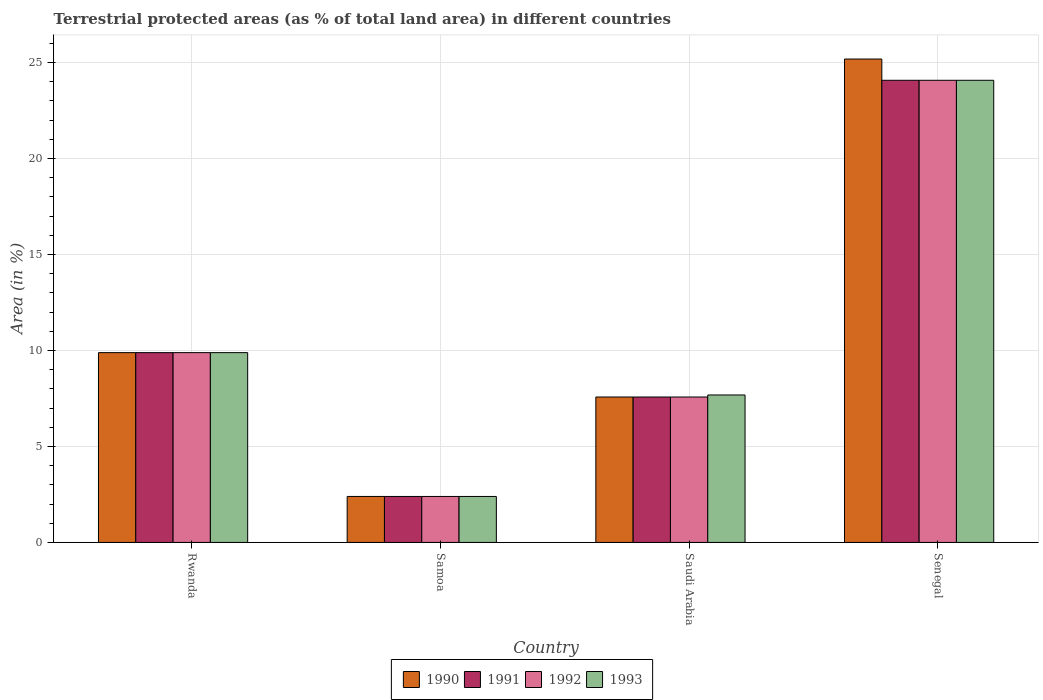How many groups of bars are there?
Offer a terse response. 4. How many bars are there on the 4th tick from the left?
Your answer should be very brief. 4. What is the label of the 2nd group of bars from the left?
Ensure brevity in your answer.  Samoa. In how many cases, is the number of bars for a given country not equal to the number of legend labels?
Offer a very short reply. 0. What is the percentage of terrestrial protected land in 1992 in Samoa?
Offer a very short reply. 2.4. Across all countries, what is the maximum percentage of terrestrial protected land in 1993?
Provide a succinct answer. 24.07. Across all countries, what is the minimum percentage of terrestrial protected land in 1990?
Offer a terse response. 2.4. In which country was the percentage of terrestrial protected land in 1993 maximum?
Your response must be concise. Senegal. In which country was the percentage of terrestrial protected land in 1991 minimum?
Your answer should be compact. Samoa. What is the total percentage of terrestrial protected land in 1991 in the graph?
Give a very brief answer. 43.93. What is the difference between the percentage of terrestrial protected land in 1990 in Rwanda and that in Samoa?
Keep it short and to the point. 7.49. What is the difference between the percentage of terrestrial protected land in 1992 in Rwanda and the percentage of terrestrial protected land in 1993 in Senegal?
Your answer should be compact. -14.19. What is the average percentage of terrestrial protected land in 1993 per country?
Your answer should be compact. 11.01. What is the difference between the percentage of terrestrial protected land of/in 1991 and percentage of terrestrial protected land of/in 1990 in Senegal?
Your response must be concise. -1.11. In how many countries, is the percentage of terrestrial protected land in 1991 greater than 19 %?
Give a very brief answer. 1. What is the ratio of the percentage of terrestrial protected land in 1990 in Samoa to that in Saudi Arabia?
Make the answer very short. 0.32. Is the percentage of terrestrial protected land in 1991 in Rwanda less than that in Senegal?
Offer a very short reply. Yes. What is the difference between the highest and the second highest percentage of terrestrial protected land in 1993?
Offer a very short reply. 14.19. What is the difference between the highest and the lowest percentage of terrestrial protected land in 1993?
Offer a terse response. 21.68. In how many countries, is the percentage of terrestrial protected land in 1993 greater than the average percentage of terrestrial protected land in 1993 taken over all countries?
Provide a succinct answer. 1. Is it the case that in every country, the sum of the percentage of terrestrial protected land in 1990 and percentage of terrestrial protected land in 1993 is greater than the percentage of terrestrial protected land in 1991?
Make the answer very short. Yes. How many bars are there?
Make the answer very short. 16. Are all the bars in the graph horizontal?
Provide a succinct answer. No. Are the values on the major ticks of Y-axis written in scientific E-notation?
Ensure brevity in your answer.  No. Does the graph contain any zero values?
Provide a succinct answer. No. Does the graph contain grids?
Your answer should be compact. Yes. What is the title of the graph?
Offer a terse response. Terrestrial protected areas (as % of total land area) in different countries. Does "1989" appear as one of the legend labels in the graph?
Offer a very short reply. No. What is the label or title of the X-axis?
Ensure brevity in your answer.  Country. What is the label or title of the Y-axis?
Keep it short and to the point. Area (in %). What is the Area (in %) of 1990 in Rwanda?
Give a very brief answer. 9.89. What is the Area (in %) of 1991 in Rwanda?
Keep it short and to the point. 9.89. What is the Area (in %) in 1992 in Rwanda?
Your answer should be compact. 9.89. What is the Area (in %) of 1993 in Rwanda?
Your answer should be very brief. 9.89. What is the Area (in %) of 1990 in Samoa?
Offer a terse response. 2.4. What is the Area (in %) of 1991 in Samoa?
Your response must be concise. 2.4. What is the Area (in %) in 1992 in Samoa?
Provide a succinct answer. 2.4. What is the Area (in %) of 1993 in Samoa?
Your answer should be very brief. 2.4. What is the Area (in %) of 1990 in Saudi Arabia?
Your answer should be compact. 7.58. What is the Area (in %) of 1991 in Saudi Arabia?
Your answer should be very brief. 7.58. What is the Area (in %) in 1992 in Saudi Arabia?
Provide a short and direct response. 7.58. What is the Area (in %) in 1993 in Saudi Arabia?
Offer a terse response. 7.68. What is the Area (in %) of 1990 in Senegal?
Ensure brevity in your answer.  25.18. What is the Area (in %) of 1991 in Senegal?
Offer a terse response. 24.07. What is the Area (in %) in 1992 in Senegal?
Make the answer very short. 24.07. What is the Area (in %) in 1993 in Senegal?
Keep it short and to the point. 24.07. Across all countries, what is the maximum Area (in %) of 1990?
Your response must be concise. 25.18. Across all countries, what is the maximum Area (in %) in 1991?
Your response must be concise. 24.07. Across all countries, what is the maximum Area (in %) in 1992?
Offer a very short reply. 24.07. Across all countries, what is the maximum Area (in %) of 1993?
Offer a terse response. 24.07. Across all countries, what is the minimum Area (in %) in 1990?
Provide a short and direct response. 2.4. Across all countries, what is the minimum Area (in %) of 1991?
Your response must be concise. 2.4. Across all countries, what is the minimum Area (in %) in 1992?
Your answer should be very brief. 2.4. Across all countries, what is the minimum Area (in %) of 1993?
Your response must be concise. 2.4. What is the total Area (in %) of 1990 in the graph?
Your answer should be very brief. 45.04. What is the total Area (in %) in 1991 in the graph?
Give a very brief answer. 43.93. What is the total Area (in %) in 1992 in the graph?
Your answer should be compact. 43.93. What is the total Area (in %) in 1993 in the graph?
Make the answer very short. 44.04. What is the difference between the Area (in %) of 1990 in Rwanda and that in Samoa?
Provide a short and direct response. 7.49. What is the difference between the Area (in %) in 1991 in Rwanda and that in Samoa?
Keep it short and to the point. 7.49. What is the difference between the Area (in %) in 1992 in Rwanda and that in Samoa?
Provide a succinct answer. 7.49. What is the difference between the Area (in %) of 1993 in Rwanda and that in Samoa?
Make the answer very short. 7.49. What is the difference between the Area (in %) of 1990 in Rwanda and that in Saudi Arabia?
Make the answer very short. 2.31. What is the difference between the Area (in %) of 1991 in Rwanda and that in Saudi Arabia?
Make the answer very short. 2.31. What is the difference between the Area (in %) in 1992 in Rwanda and that in Saudi Arabia?
Provide a succinct answer. 2.31. What is the difference between the Area (in %) of 1993 in Rwanda and that in Saudi Arabia?
Keep it short and to the point. 2.21. What is the difference between the Area (in %) in 1990 in Rwanda and that in Senegal?
Your answer should be very brief. -15.29. What is the difference between the Area (in %) in 1991 in Rwanda and that in Senegal?
Ensure brevity in your answer.  -14.19. What is the difference between the Area (in %) in 1992 in Rwanda and that in Senegal?
Offer a terse response. -14.19. What is the difference between the Area (in %) of 1993 in Rwanda and that in Senegal?
Offer a very short reply. -14.19. What is the difference between the Area (in %) of 1990 in Samoa and that in Saudi Arabia?
Offer a very short reply. -5.18. What is the difference between the Area (in %) in 1991 in Samoa and that in Saudi Arabia?
Provide a short and direct response. -5.18. What is the difference between the Area (in %) in 1992 in Samoa and that in Saudi Arabia?
Offer a terse response. -5.18. What is the difference between the Area (in %) in 1993 in Samoa and that in Saudi Arabia?
Your answer should be compact. -5.29. What is the difference between the Area (in %) in 1990 in Samoa and that in Senegal?
Your answer should be compact. -22.79. What is the difference between the Area (in %) in 1991 in Samoa and that in Senegal?
Keep it short and to the point. -21.68. What is the difference between the Area (in %) of 1992 in Samoa and that in Senegal?
Provide a succinct answer. -21.68. What is the difference between the Area (in %) of 1993 in Samoa and that in Senegal?
Provide a short and direct response. -21.68. What is the difference between the Area (in %) in 1990 in Saudi Arabia and that in Senegal?
Keep it short and to the point. -17.6. What is the difference between the Area (in %) of 1991 in Saudi Arabia and that in Senegal?
Your answer should be very brief. -16.5. What is the difference between the Area (in %) of 1992 in Saudi Arabia and that in Senegal?
Offer a terse response. -16.5. What is the difference between the Area (in %) of 1993 in Saudi Arabia and that in Senegal?
Give a very brief answer. -16.39. What is the difference between the Area (in %) in 1990 in Rwanda and the Area (in %) in 1991 in Samoa?
Your response must be concise. 7.49. What is the difference between the Area (in %) of 1990 in Rwanda and the Area (in %) of 1992 in Samoa?
Your answer should be compact. 7.49. What is the difference between the Area (in %) in 1990 in Rwanda and the Area (in %) in 1993 in Samoa?
Make the answer very short. 7.49. What is the difference between the Area (in %) in 1991 in Rwanda and the Area (in %) in 1992 in Samoa?
Keep it short and to the point. 7.49. What is the difference between the Area (in %) in 1991 in Rwanda and the Area (in %) in 1993 in Samoa?
Keep it short and to the point. 7.49. What is the difference between the Area (in %) of 1992 in Rwanda and the Area (in %) of 1993 in Samoa?
Your response must be concise. 7.49. What is the difference between the Area (in %) of 1990 in Rwanda and the Area (in %) of 1991 in Saudi Arabia?
Offer a very short reply. 2.31. What is the difference between the Area (in %) of 1990 in Rwanda and the Area (in %) of 1992 in Saudi Arabia?
Offer a very short reply. 2.31. What is the difference between the Area (in %) of 1990 in Rwanda and the Area (in %) of 1993 in Saudi Arabia?
Offer a very short reply. 2.21. What is the difference between the Area (in %) of 1991 in Rwanda and the Area (in %) of 1992 in Saudi Arabia?
Provide a succinct answer. 2.31. What is the difference between the Area (in %) in 1991 in Rwanda and the Area (in %) in 1993 in Saudi Arabia?
Keep it short and to the point. 2.21. What is the difference between the Area (in %) in 1992 in Rwanda and the Area (in %) in 1993 in Saudi Arabia?
Keep it short and to the point. 2.21. What is the difference between the Area (in %) in 1990 in Rwanda and the Area (in %) in 1991 in Senegal?
Give a very brief answer. -14.19. What is the difference between the Area (in %) of 1990 in Rwanda and the Area (in %) of 1992 in Senegal?
Give a very brief answer. -14.19. What is the difference between the Area (in %) of 1990 in Rwanda and the Area (in %) of 1993 in Senegal?
Offer a terse response. -14.19. What is the difference between the Area (in %) of 1991 in Rwanda and the Area (in %) of 1992 in Senegal?
Provide a succinct answer. -14.19. What is the difference between the Area (in %) in 1991 in Rwanda and the Area (in %) in 1993 in Senegal?
Provide a short and direct response. -14.19. What is the difference between the Area (in %) in 1992 in Rwanda and the Area (in %) in 1993 in Senegal?
Offer a terse response. -14.19. What is the difference between the Area (in %) of 1990 in Samoa and the Area (in %) of 1991 in Saudi Arabia?
Offer a very short reply. -5.18. What is the difference between the Area (in %) of 1990 in Samoa and the Area (in %) of 1992 in Saudi Arabia?
Your answer should be compact. -5.18. What is the difference between the Area (in %) in 1990 in Samoa and the Area (in %) in 1993 in Saudi Arabia?
Ensure brevity in your answer.  -5.29. What is the difference between the Area (in %) of 1991 in Samoa and the Area (in %) of 1992 in Saudi Arabia?
Provide a succinct answer. -5.18. What is the difference between the Area (in %) of 1991 in Samoa and the Area (in %) of 1993 in Saudi Arabia?
Your response must be concise. -5.29. What is the difference between the Area (in %) of 1992 in Samoa and the Area (in %) of 1993 in Saudi Arabia?
Your answer should be compact. -5.29. What is the difference between the Area (in %) of 1990 in Samoa and the Area (in %) of 1991 in Senegal?
Your answer should be very brief. -21.68. What is the difference between the Area (in %) of 1990 in Samoa and the Area (in %) of 1992 in Senegal?
Provide a succinct answer. -21.68. What is the difference between the Area (in %) of 1990 in Samoa and the Area (in %) of 1993 in Senegal?
Your answer should be compact. -21.68. What is the difference between the Area (in %) of 1991 in Samoa and the Area (in %) of 1992 in Senegal?
Your answer should be very brief. -21.68. What is the difference between the Area (in %) in 1991 in Samoa and the Area (in %) in 1993 in Senegal?
Give a very brief answer. -21.68. What is the difference between the Area (in %) in 1992 in Samoa and the Area (in %) in 1993 in Senegal?
Provide a short and direct response. -21.68. What is the difference between the Area (in %) in 1990 in Saudi Arabia and the Area (in %) in 1991 in Senegal?
Provide a short and direct response. -16.5. What is the difference between the Area (in %) of 1990 in Saudi Arabia and the Area (in %) of 1992 in Senegal?
Provide a succinct answer. -16.5. What is the difference between the Area (in %) of 1990 in Saudi Arabia and the Area (in %) of 1993 in Senegal?
Your response must be concise. -16.5. What is the difference between the Area (in %) in 1991 in Saudi Arabia and the Area (in %) in 1992 in Senegal?
Keep it short and to the point. -16.5. What is the difference between the Area (in %) in 1991 in Saudi Arabia and the Area (in %) in 1993 in Senegal?
Offer a very short reply. -16.5. What is the difference between the Area (in %) of 1992 in Saudi Arabia and the Area (in %) of 1993 in Senegal?
Give a very brief answer. -16.5. What is the average Area (in %) in 1990 per country?
Make the answer very short. 11.26. What is the average Area (in %) of 1991 per country?
Provide a short and direct response. 10.98. What is the average Area (in %) in 1992 per country?
Your response must be concise. 10.98. What is the average Area (in %) of 1993 per country?
Your answer should be very brief. 11.01. What is the difference between the Area (in %) of 1990 and Area (in %) of 1992 in Rwanda?
Your answer should be very brief. 0. What is the difference between the Area (in %) in 1990 and Area (in %) in 1993 in Rwanda?
Your response must be concise. 0. What is the difference between the Area (in %) of 1991 and Area (in %) of 1993 in Rwanda?
Offer a terse response. 0. What is the difference between the Area (in %) of 1990 and Area (in %) of 1993 in Samoa?
Offer a very short reply. 0. What is the difference between the Area (in %) of 1991 and Area (in %) of 1993 in Samoa?
Your answer should be very brief. 0. What is the difference between the Area (in %) of 1990 and Area (in %) of 1992 in Saudi Arabia?
Give a very brief answer. 0. What is the difference between the Area (in %) of 1990 and Area (in %) of 1993 in Saudi Arabia?
Make the answer very short. -0.11. What is the difference between the Area (in %) in 1991 and Area (in %) in 1992 in Saudi Arabia?
Keep it short and to the point. 0. What is the difference between the Area (in %) in 1991 and Area (in %) in 1993 in Saudi Arabia?
Your answer should be very brief. -0.11. What is the difference between the Area (in %) of 1992 and Area (in %) of 1993 in Saudi Arabia?
Keep it short and to the point. -0.11. What is the difference between the Area (in %) in 1990 and Area (in %) in 1991 in Senegal?
Ensure brevity in your answer.  1.11. What is the difference between the Area (in %) of 1990 and Area (in %) of 1992 in Senegal?
Your answer should be compact. 1.11. What is the difference between the Area (in %) in 1990 and Area (in %) in 1993 in Senegal?
Your response must be concise. 1.11. What is the difference between the Area (in %) of 1992 and Area (in %) of 1993 in Senegal?
Give a very brief answer. 0. What is the ratio of the Area (in %) in 1990 in Rwanda to that in Samoa?
Offer a very short reply. 4.13. What is the ratio of the Area (in %) in 1991 in Rwanda to that in Samoa?
Provide a short and direct response. 4.13. What is the ratio of the Area (in %) in 1992 in Rwanda to that in Samoa?
Offer a terse response. 4.13. What is the ratio of the Area (in %) of 1993 in Rwanda to that in Samoa?
Keep it short and to the point. 4.13. What is the ratio of the Area (in %) of 1990 in Rwanda to that in Saudi Arabia?
Your answer should be compact. 1.31. What is the ratio of the Area (in %) of 1991 in Rwanda to that in Saudi Arabia?
Keep it short and to the point. 1.31. What is the ratio of the Area (in %) of 1992 in Rwanda to that in Saudi Arabia?
Provide a short and direct response. 1.31. What is the ratio of the Area (in %) of 1993 in Rwanda to that in Saudi Arabia?
Make the answer very short. 1.29. What is the ratio of the Area (in %) of 1990 in Rwanda to that in Senegal?
Provide a succinct answer. 0.39. What is the ratio of the Area (in %) in 1991 in Rwanda to that in Senegal?
Offer a terse response. 0.41. What is the ratio of the Area (in %) of 1992 in Rwanda to that in Senegal?
Make the answer very short. 0.41. What is the ratio of the Area (in %) in 1993 in Rwanda to that in Senegal?
Make the answer very short. 0.41. What is the ratio of the Area (in %) in 1990 in Samoa to that in Saudi Arabia?
Your response must be concise. 0.32. What is the ratio of the Area (in %) of 1991 in Samoa to that in Saudi Arabia?
Your answer should be compact. 0.32. What is the ratio of the Area (in %) in 1992 in Samoa to that in Saudi Arabia?
Your response must be concise. 0.32. What is the ratio of the Area (in %) of 1993 in Samoa to that in Saudi Arabia?
Ensure brevity in your answer.  0.31. What is the ratio of the Area (in %) in 1990 in Samoa to that in Senegal?
Ensure brevity in your answer.  0.1. What is the ratio of the Area (in %) in 1991 in Samoa to that in Senegal?
Provide a short and direct response. 0.1. What is the ratio of the Area (in %) of 1992 in Samoa to that in Senegal?
Your answer should be very brief. 0.1. What is the ratio of the Area (in %) in 1993 in Samoa to that in Senegal?
Offer a terse response. 0.1. What is the ratio of the Area (in %) of 1990 in Saudi Arabia to that in Senegal?
Provide a succinct answer. 0.3. What is the ratio of the Area (in %) of 1991 in Saudi Arabia to that in Senegal?
Keep it short and to the point. 0.31. What is the ratio of the Area (in %) of 1992 in Saudi Arabia to that in Senegal?
Make the answer very short. 0.31. What is the ratio of the Area (in %) in 1993 in Saudi Arabia to that in Senegal?
Offer a terse response. 0.32. What is the difference between the highest and the second highest Area (in %) of 1990?
Ensure brevity in your answer.  15.29. What is the difference between the highest and the second highest Area (in %) in 1991?
Your answer should be very brief. 14.19. What is the difference between the highest and the second highest Area (in %) in 1992?
Keep it short and to the point. 14.19. What is the difference between the highest and the second highest Area (in %) of 1993?
Ensure brevity in your answer.  14.19. What is the difference between the highest and the lowest Area (in %) of 1990?
Offer a terse response. 22.79. What is the difference between the highest and the lowest Area (in %) in 1991?
Offer a terse response. 21.68. What is the difference between the highest and the lowest Area (in %) in 1992?
Provide a succinct answer. 21.68. What is the difference between the highest and the lowest Area (in %) of 1993?
Make the answer very short. 21.68. 